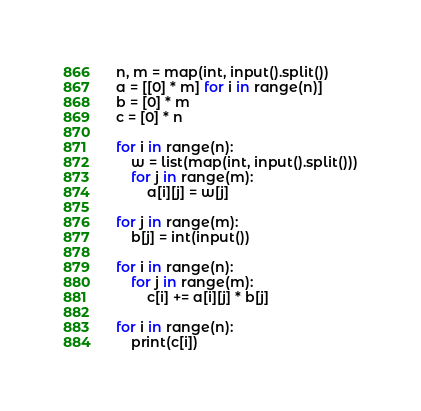<code> <loc_0><loc_0><loc_500><loc_500><_Python_>n, m = map(int, input().split())
a = [[0] * m] for i in range(n)]
b = [0] * m
c = [0] * n

for i in range(n):
    w = list(map(int, input().split()))
    for j in range(m):
        a[i][j] = w[j]

for j in range(m):
    b[j] = int(input())

for i in range(n):
    for j in range(m):
        c[i] += a[i][j] * b[j]

for i in range(n):
    print(c[i])</code> 